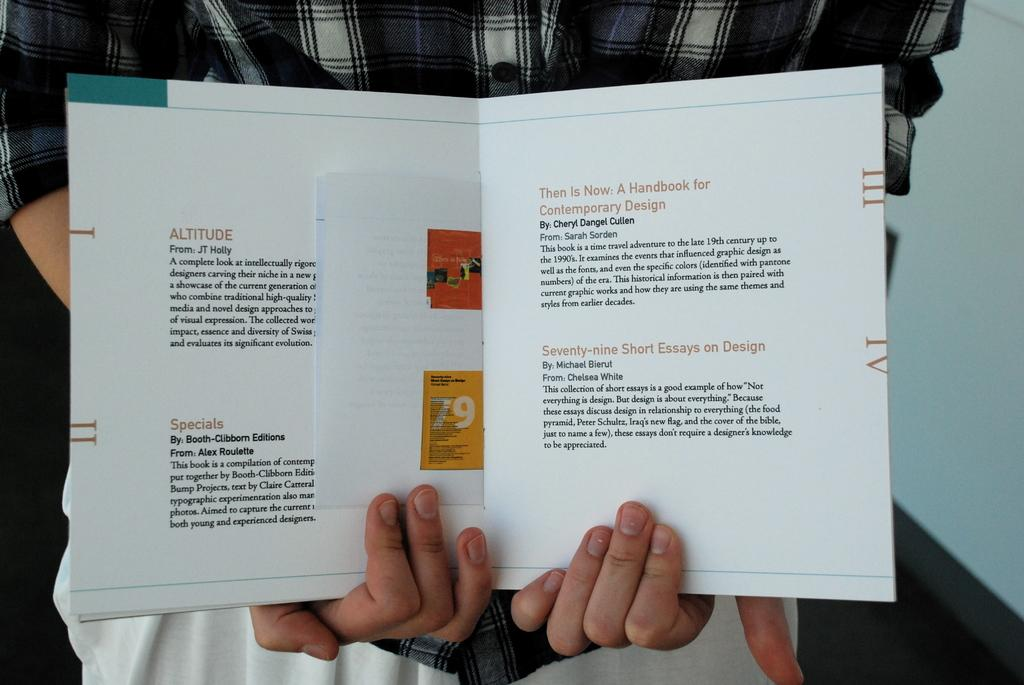<image>
Share a concise interpretation of the image provided. A person holding open a booklet that has several topics, one of which is Altitude. 